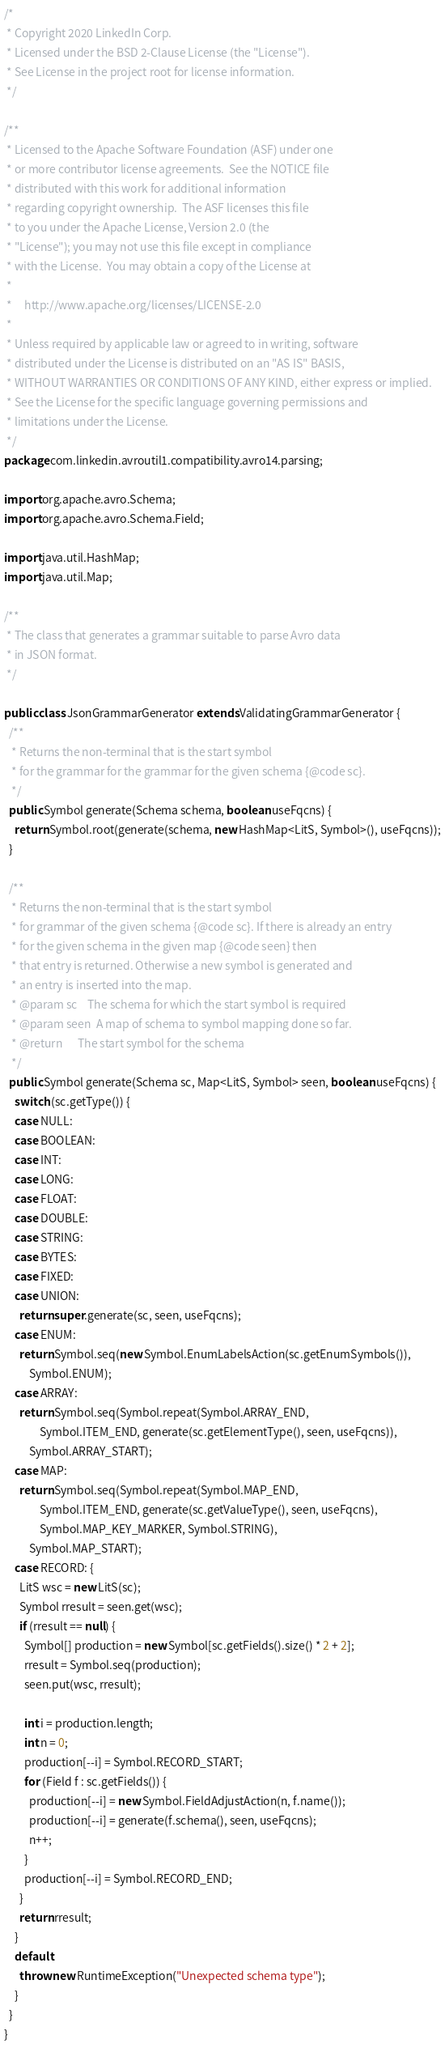<code> <loc_0><loc_0><loc_500><loc_500><_Java_>/*
 * Copyright 2020 LinkedIn Corp.
 * Licensed under the BSD 2-Clause License (the "License").
 * See License in the project root for license information.
 */

/**
 * Licensed to the Apache Software Foundation (ASF) under one
 * or more contributor license agreements.  See the NOTICE file
 * distributed with this work for additional information
 * regarding copyright ownership.  The ASF licenses this file
 * to you under the Apache License, Version 2.0 (the
 * "License"); you may not use this file except in compliance
 * with the License.  You may obtain a copy of the License at
 *
 *     http://www.apache.org/licenses/LICENSE-2.0
 *
 * Unless required by applicable law or agreed to in writing, software
 * distributed under the License is distributed on an "AS IS" BASIS,
 * WITHOUT WARRANTIES OR CONDITIONS OF ANY KIND, either express or implied.
 * See the License for the specific language governing permissions and
 * limitations under the License.
 */
package com.linkedin.avroutil1.compatibility.avro14.parsing;

import org.apache.avro.Schema;
import org.apache.avro.Schema.Field;

import java.util.HashMap;
import java.util.Map;

/**
 * The class that generates a grammar suitable to parse Avro data
 * in JSON format.
 */

public class JsonGrammarGenerator extends ValidatingGrammarGenerator {
  /**
   * Returns the non-terminal that is the start symbol
   * for the grammar for the grammar for the given schema {@code sc}.
   */
  public Symbol generate(Schema schema, boolean useFqcns) {
    return Symbol.root(generate(schema, new HashMap<LitS, Symbol>(), useFqcns));
  }

  /**
   * Returns the non-terminal that is the start symbol
   * for grammar of the given schema {@code sc}. If there is already an entry
   * for the given schema in the given map {@code seen} then
   * that entry is returned. Otherwise a new symbol is generated and
   * an entry is inserted into the map.
   * @param sc    The schema for which the start symbol is required
   * @param seen  A map of schema to symbol mapping done so far.
   * @return      The start symbol for the schema
   */
  public Symbol generate(Schema sc, Map<LitS, Symbol> seen, boolean useFqcns) {
    switch (sc.getType()) {
    case NULL:
    case BOOLEAN:
    case INT:
    case LONG:
    case FLOAT:
    case DOUBLE:
    case STRING:
    case BYTES:
    case FIXED:
    case UNION:
      return super.generate(sc, seen, useFqcns);
    case ENUM:
      return Symbol.seq(new Symbol.EnumLabelsAction(sc.getEnumSymbols()),
          Symbol.ENUM);
    case ARRAY:
      return Symbol.seq(Symbol.repeat(Symbol.ARRAY_END,
              Symbol.ITEM_END, generate(sc.getElementType(), seen, useFqcns)),
          Symbol.ARRAY_START);
    case MAP:
      return Symbol.seq(Symbol.repeat(Symbol.MAP_END,
              Symbol.ITEM_END, generate(sc.getValueType(), seen, useFqcns),
              Symbol.MAP_KEY_MARKER, Symbol.STRING),
          Symbol.MAP_START);
    case RECORD: {
      LitS wsc = new LitS(sc);
      Symbol rresult = seen.get(wsc);
      if (rresult == null) {
        Symbol[] production = new Symbol[sc.getFields().size() * 2 + 2];
        rresult = Symbol.seq(production);
        seen.put(wsc, rresult);

        int i = production.length;
        int n = 0;
        production[--i] = Symbol.RECORD_START;
        for (Field f : sc.getFields()) {
          production[--i] = new Symbol.FieldAdjustAction(n, f.name());
          production[--i] = generate(f.schema(), seen, useFqcns);
          n++;
        }
        production[--i] = Symbol.RECORD_END;
      }
      return rresult;
    }
    default:
      throw new RuntimeException("Unexpected schema type");
    }
  }
}

</code> 